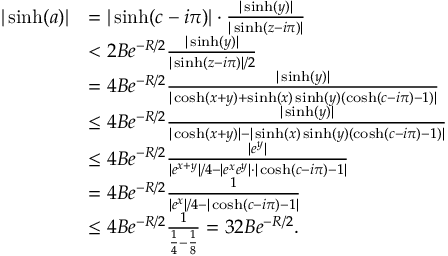Convert formula to latex. <formula><loc_0><loc_0><loc_500><loc_500>\begin{array} { r l } { | \sinh ( a ) | } & { = | \sinh ( c - i \pi ) | \cdot \frac { | \sinh ( y ) | } { | \sinh ( z - i \pi ) | } } \\ & { < 2 B e ^ { - R / 2 } \frac { | \sinh ( y ) | } { | \sinh ( z - i \pi ) | / 2 } } \\ & { = 4 B e ^ { - R / 2 } \frac { | \sinh ( y ) | } { | \cosh ( x + y ) + \sinh ( x ) \sinh ( y ) ( \cosh ( c - i \pi ) - 1 ) | } } \\ & { \leq 4 B e ^ { - R / 2 } \frac { | \sinh ( y ) | } { | \cosh ( x + y ) | - | \sinh ( x ) \sinh ( y ) ( \cosh ( c - i \pi ) - 1 ) | } } \\ & { \leq 4 B e ^ { - R / 2 } \frac { | e ^ { y } | } { | e ^ { x + y } | / 4 - | e ^ { x } e ^ { y } | \cdot | \cosh ( c - i \pi ) - 1 | } } \\ & { = 4 B e ^ { - R / 2 } \frac { 1 } { | e ^ { x } | / 4 - | \cosh ( c - i \pi ) - 1 | } } \\ & { \leq 4 B e ^ { - R / 2 } \frac { 1 } { \frac { 1 } { 4 } - \frac { 1 } { 8 } } = 3 2 B e ^ { - R / 2 } . } \end{array}</formula> 